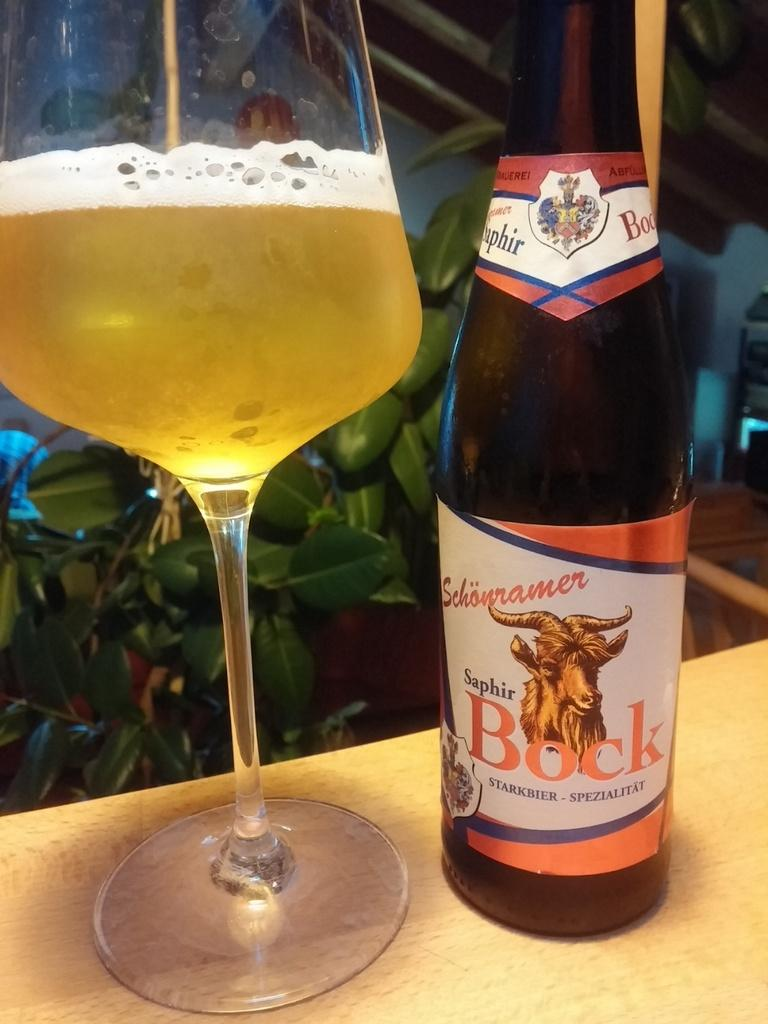What type of beverage is featured in the image? There is a wine bottle and a glass of wine in the image. Where are the wine bottle and glass placed? They are placed on a wooden surface. What can be seen in the background of the image? There is a plant in the background of the image. What type of vessel is being used by the actor in the image? There is no actor present in the image, and therefore no vessel being used by an actor. Can you tell me the profession of the lawyer in the image? There is no lawyer present in the image. 